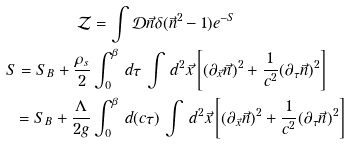<formula> <loc_0><loc_0><loc_500><loc_500>\mathcal { Z } & = \int \mathcal { D } \vec { n } \delta ( \vec { n } ^ { 2 } - 1 ) e ^ { - S } \\ S = S _ { B } + \frac { \rho _ { s } } { 2 } & \int _ { 0 } ^ { \beta } \, d \tau \, \int \, d ^ { 2 } \vec { x } \left [ ( \partial _ { \vec { x } } \vec { n } ) ^ { 2 } + \frac { 1 } { c ^ { 2 } } ( \partial _ { \tau } \vec { n } ) ^ { 2 } \right ] \\ = S _ { B } + \frac { \Lambda } { 2 g } & \int _ { 0 } ^ { \beta } \, d ( c \tau ) \, \int \, d ^ { 2 } \vec { x } \left [ ( \partial _ { \vec { x } } \vec { n } ) ^ { 2 } + \frac { 1 } { c ^ { 2 } } ( \partial _ { \tau } \vec { n } ) ^ { 2 } \right ]</formula> 